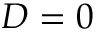<formula> <loc_0><loc_0><loc_500><loc_500>D = 0</formula> 